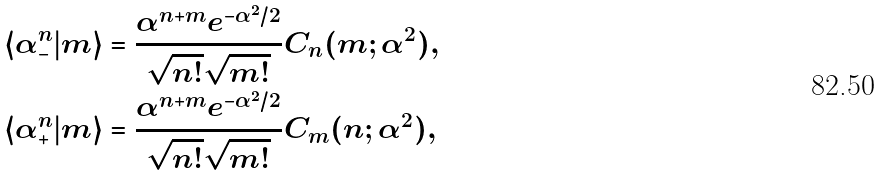<formula> <loc_0><loc_0><loc_500><loc_500>\langle \alpha _ { - } ^ { n } | m \rangle & = \frac { \alpha ^ { n + m } e ^ { - \alpha ^ { 2 } / 2 } } { \sqrt { n ! } \sqrt { m ! } } C _ { n } ( m ; \alpha ^ { 2 } ) , \\ \langle \alpha _ { + } ^ { n } | m \rangle & = \frac { \alpha ^ { n + m } e ^ { - \alpha ^ { 2 } / 2 } } { \sqrt { n ! } \sqrt { m ! } } C _ { m } ( n ; \alpha ^ { 2 } ) ,</formula> 